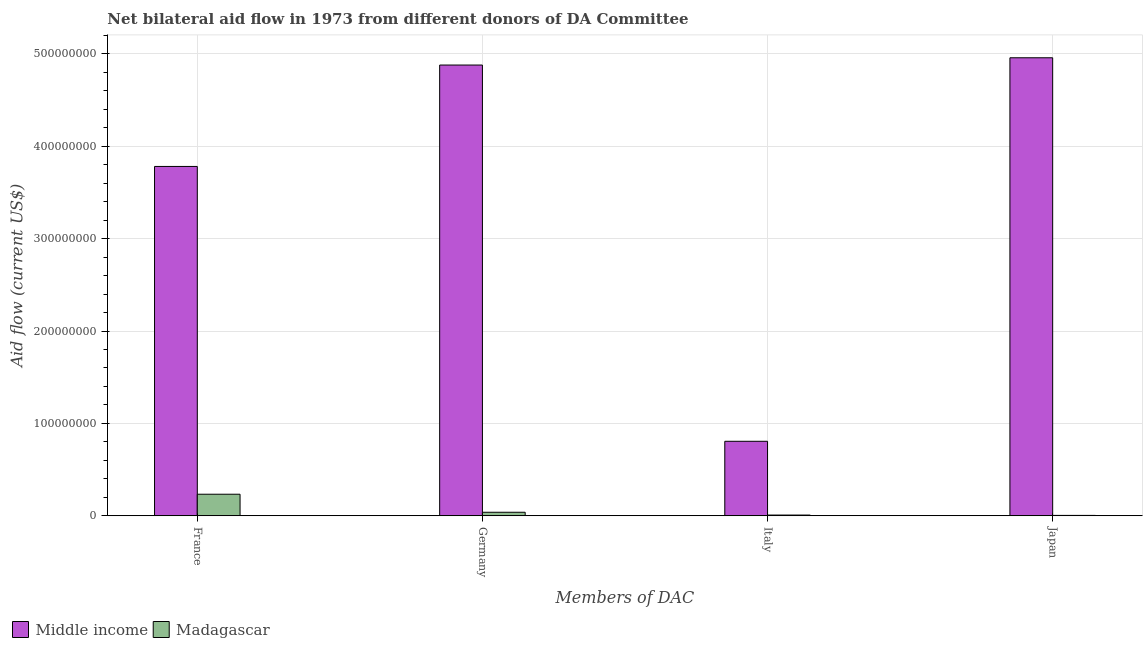How many different coloured bars are there?
Offer a terse response. 2. How many groups of bars are there?
Offer a terse response. 4. Are the number of bars per tick equal to the number of legend labels?
Provide a succinct answer. Yes. Are the number of bars on each tick of the X-axis equal?
Your answer should be very brief. Yes. How many bars are there on the 2nd tick from the left?
Your answer should be compact. 2. How many bars are there on the 4th tick from the right?
Your answer should be very brief. 2. What is the label of the 4th group of bars from the left?
Your answer should be compact. Japan. What is the amount of aid given by germany in Madagascar?
Your answer should be very brief. 3.83e+06. Across all countries, what is the maximum amount of aid given by italy?
Provide a short and direct response. 8.06e+07. Across all countries, what is the minimum amount of aid given by italy?
Give a very brief answer. 8.00e+05. In which country was the amount of aid given by france maximum?
Offer a terse response. Middle income. In which country was the amount of aid given by france minimum?
Give a very brief answer. Madagascar. What is the total amount of aid given by france in the graph?
Your answer should be compact. 4.01e+08. What is the difference between the amount of aid given by japan in Madagascar and that in Middle income?
Make the answer very short. -4.95e+08. What is the difference between the amount of aid given by germany in Middle income and the amount of aid given by france in Madagascar?
Provide a short and direct response. 4.65e+08. What is the average amount of aid given by japan per country?
Your response must be concise. 2.48e+08. What is the difference between the amount of aid given by italy and amount of aid given by france in Middle income?
Keep it short and to the point. -2.98e+08. What is the ratio of the amount of aid given by japan in Madagascar to that in Middle income?
Give a very brief answer. 0. Is the amount of aid given by germany in Middle income less than that in Madagascar?
Provide a succinct answer. No. Is the difference between the amount of aid given by italy in Middle income and Madagascar greater than the difference between the amount of aid given by france in Middle income and Madagascar?
Provide a succinct answer. No. What is the difference between the highest and the second highest amount of aid given by germany?
Your answer should be very brief. 4.84e+08. What is the difference between the highest and the lowest amount of aid given by italy?
Ensure brevity in your answer.  7.98e+07. In how many countries, is the amount of aid given by japan greater than the average amount of aid given by japan taken over all countries?
Make the answer very short. 1. What does the 1st bar from the left in Germany represents?
Your answer should be compact. Middle income. What does the 1st bar from the right in Italy represents?
Provide a short and direct response. Madagascar. Are all the bars in the graph horizontal?
Your answer should be very brief. No. How many countries are there in the graph?
Provide a succinct answer. 2. What is the difference between two consecutive major ticks on the Y-axis?
Give a very brief answer. 1.00e+08. Are the values on the major ticks of Y-axis written in scientific E-notation?
Offer a very short reply. No. Where does the legend appear in the graph?
Provide a succinct answer. Bottom left. What is the title of the graph?
Your response must be concise. Net bilateral aid flow in 1973 from different donors of DA Committee. What is the label or title of the X-axis?
Your answer should be very brief. Members of DAC. What is the label or title of the Y-axis?
Give a very brief answer. Aid flow (current US$). What is the Aid flow (current US$) of Middle income in France?
Your answer should be very brief. 3.78e+08. What is the Aid flow (current US$) in Madagascar in France?
Your answer should be very brief. 2.34e+07. What is the Aid flow (current US$) of Middle income in Germany?
Your answer should be very brief. 4.88e+08. What is the Aid flow (current US$) in Madagascar in Germany?
Ensure brevity in your answer.  3.83e+06. What is the Aid flow (current US$) of Middle income in Italy?
Your answer should be very brief. 8.06e+07. What is the Aid flow (current US$) of Madagascar in Italy?
Keep it short and to the point. 8.00e+05. What is the Aid flow (current US$) of Middle income in Japan?
Provide a short and direct response. 4.96e+08. Across all Members of DAC, what is the maximum Aid flow (current US$) of Middle income?
Offer a very short reply. 4.96e+08. Across all Members of DAC, what is the maximum Aid flow (current US$) in Madagascar?
Offer a terse response. 2.34e+07. Across all Members of DAC, what is the minimum Aid flow (current US$) of Middle income?
Keep it short and to the point. 8.06e+07. What is the total Aid flow (current US$) in Middle income in the graph?
Provide a succinct answer. 1.44e+09. What is the total Aid flow (current US$) in Madagascar in the graph?
Provide a short and direct response. 2.84e+07. What is the difference between the Aid flow (current US$) of Middle income in France and that in Germany?
Your answer should be very brief. -1.10e+08. What is the difference between the Aid flow (current US$) of Madagascar in France and that in Germany?
Keep it short and to the point. 1.95e+07. What is the difference between the Aid flow (current US$) of Middle income in France and that in Italy?
Offer a very short reply. 2.98e+08. What is the difference between the Aid flow (current US$) in Madagascar in France and that in Italy?
Offer a terse response. 2.26e+07. What is the difference between the Aid flow (current US$) of Middle income in France and that in Japan?
Your answer should be very brief. -1.18e+08. What is the difference between the Aid flow (current US$) in Madagascar in France and that in Japan?
Offer a very short reply. 2.29e+07. What is the difference between the Aid flow (current US$) of Middle income in Germany and that in Italy?
Provide a succinct answer. 4.07e+08. What is the difference between the Aid flow (current US$) in Madagascar in Germany and that in Italy?
Keep it short and to the point. 3.03e+06. What is the difference between the Aid flow (current US$) of Middle income in Germany and that in Japan?
Provide a succinct answer. -7.87e+06. What is the difference between the Aid flow (current US$) of Madagascar in Germany and that in Japan?
Your answer should be compact. 3.41e+06. What is the difference between the Aid flow (current US$) of Middle income in Italy and that in Japan?
Offer a very short reply. -4.15e+08. What is the difference between the Aid flow (current US$) in Middle income in France and the Aid flow (current US$) in Madagascar in Germany?
Keep it short and to the point. 3.74e+08. What is the difference between the Aid flow (current US$) of Middle income in France and the Aid flow (current US$) of Madagascar in Italy?
Make the answer very short. 3.77e+08. What is the difference between the Aid flow (current US$) of Middle income in France and the Aid flow (current US$) of Madagascar in Japan?
Give a very brief answer. 3.78e+08. What is the difference between the Aid flow (current US$) of Middle income in Germany and the Aid flow (current US$) of Madagascar in Italy?
Give a very brief answer. 4.87e+08. What is the difference between the Aid flow (current US$) in Middle income in Germany and the Aid flow (current US$) in Madagascar in Japan?
Offer a terse response. 4.87e+08. What is the difference between the Aid flow (current US$) in Middle income in Italy and the Aid flow (current US$) in Madagascar in Japan?
Ensure brevity in your answer.  8.02e+07. What is the average Aid flow (current US$) in Middle income per Members of DAC?
Offer a very short reply. 3.61e+08. What is the average Aid flow (current US$) of Madagascar per Members of DAC?
Make the answer very short. 7.10e+06. What is the difference between the Aid flow (current US$) in Middle income and Aid flow (current US$) in Madagascar in France?
Ensure brevity in your answer.  3.55e+08. What is the difference between the Aid flow (current US$) in Middle income and Aid flow (current US$) in Madagascar in Germany?
Offer a terse response. 4.84e+08. What is the difference between the Aid flow (current US$) of Middle income and Aid flow (current US$) of Madagascar in Italy?
Keep it short and to the point. 7.98e+07. What is the difference between the Aid flow (current US$) of Middle income and Aid flow (current US$) of Madagascar in Japan?
Give a very brief answer. 4.95e+08. What is the ratio of the Aid flow (current US$) of Middle income in France to that in Germany?
Make the answer very short. 0.78. What is the ratio of the Aid flow (current US$) of Madagascar in France to that in Germany?
Give a very brief answer. 6.1. What is the ratio of the Aid flow (current US$) of Middle income in France to that in Italy?
Provide a succinct answer. 4.69. What is the ratio of the Aid flow (current US$) of Madagascar in France to that in Italy?
Make the answer very short. 29.19. What is the ratio of the Aid flow (current US$) in Middle income in France to that in Japan?
Ensure brevity in your answer.  0.76. What is the ratio of the Aid flow (current US$) of Madagascar in France to that in Japan?
Offer a very short reply. 55.6. What is the ratio of the Aid flow (current US$) in Middle income in Germany to that in Italy?
Provide a short and direct response. 6.05. What is the ratio of the Aid flow (current US$) in Madagascar in Germany to that in Italy?
Your answer should be compact. 4.79. What is the ratio of the Aid flow (current US$) in Middle income in Germany to that in Japan?
Make the answer very short. 0.98. What is the ratio of the Aid flow (current US$) in Madagascar in Germany to that in Japan?
Your response must be concise. 9.12. What is the ratio of the Aid flow (current US$) of Middle income in Italy to that in Japan?
Make the answer very short. 0.16. What is the ratio of the Aid flow (current US$) in Madagascar in Italy to that in Japan?
Your response must be concise. 1.9. What is the difference between the highest and the second highest Aid flow (current US$) of Middle income?
Provide a short and direct response. 7.87e+06. What is the difference between the highest and the second highest Aid flow (current US$) in Madagascar?
Offer a very short reply. 1.95e+07. What is the difference between the highest and the lowest Aid flow (current US$) in Middle income?
Your answer should be compact. 4.15e+08. What is the difference between the highest and the lowest Aid flow (current US$) of Madagascar?
Make the answer very short. 2.29e+07. 